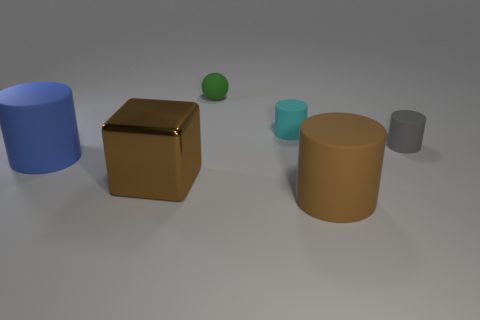There is a matte object that is both left of the cyan matte cylinder and to the right of the shiny object; how big is it?
Give a very brief answer. Small. What shape is the tiny cyan object?
Make the answer very short. Cylinder. There is a large cylinder that is behind the large brown rubber cylinder; are there any big blocks that are to the left of it?
Keep it short and to the point. No. What number of big cylinders are to the left of the rubber cylinder that is behind the small gray object?
Offer a terse response. 1. What material is the gray cylinder that is the same size as the ball?
Ensure brevity in your answer.  Rubber. Is the shape of the big thing behind the big brown shiny object the same as  the big brown matte object?
Give a very brief answer. Yes. Are there more brown rubber cylinders to the left of the brown cylinder than brown metal cubes behind the ball?
Provide a short and direct response. No. How many large brown cylinders are made of the same material as the small cyan cylinder?
Provide a succinct answer. 1. Is the gray matte cylinder the same size as the blue object?
Provide a short and direct response. No. What is the color of the metallic object?
Your answer should be compact. Brown. 